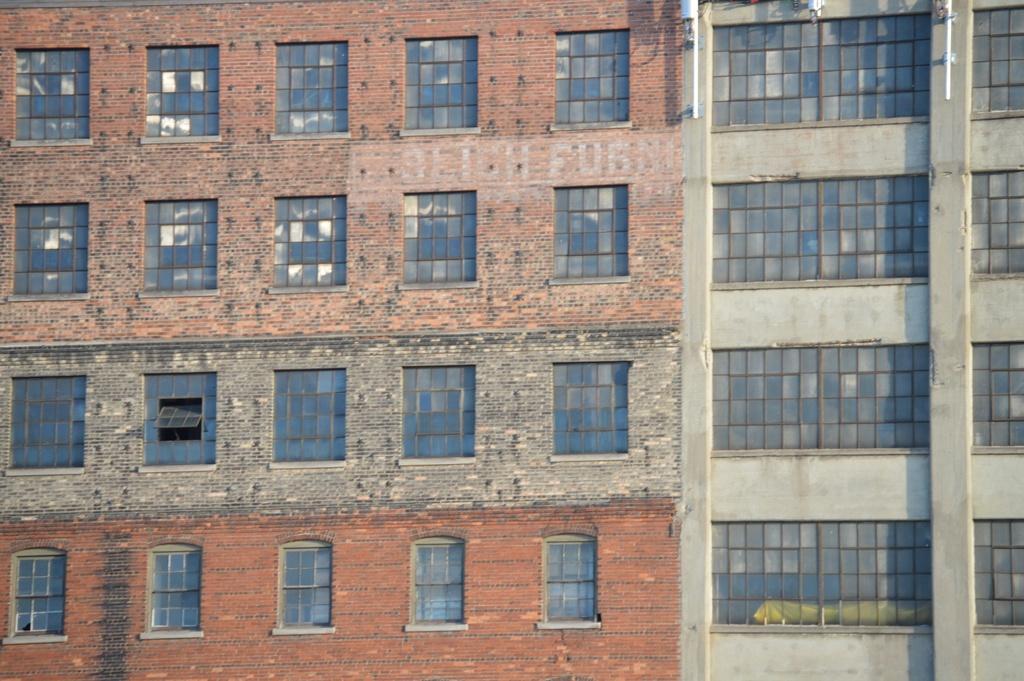Describe this image in one or two sentences. In the foreground of this image, there are windows of buildings. 